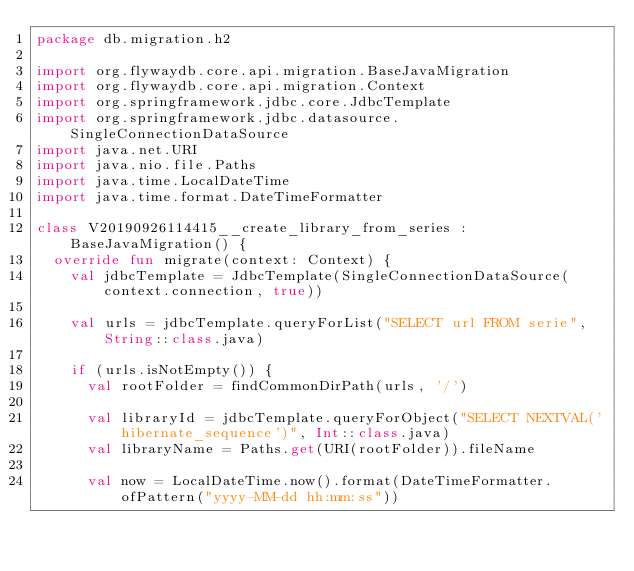<code> <loc_0><loc_0><loc_500><loc_500><_Kotlin_>package db.migration.h2

import org.flywaydb.core.api.migration.BaseJavaMigration
import org.flywaydb.core.api.migration.Context
import org.springframework.jdbc.core.JdbcTemplate
import org.springframework.jdbc.datasource.SingleConnectionDataSource
import java.net.URI
import java.nio.file.Paths
import java.time.LocalDateTime
import java.time.format.DateTimeFormatter

class V20190926114415__create_library_from_series : BaseJavaMigration() {
  override fun migrate(context: Context) {
    val jdbcTemplate = JdbcTemplate(SingleConnectionDataSource(context.connection, true))

    val urls = jdbcTemplate.queryForList("SELECT url FROM serie", String::class.java)

    if (urls.isNotEmpty()) {
      val rootFolder = findCommonDirPath(urls, '/')

      val libraryId = jdbcTemplate.queryForObject("SELECT NEXTVAL('hibernate_sequence')", Int::class.java)
      val libraryName = Paths.get(URI(rootFolder)).fileName

      val now = LocalDateTime.now().format(DateTimeFormatter.ofPattern("yyyy-MM-dd hh:mm:ss"))
</code> 